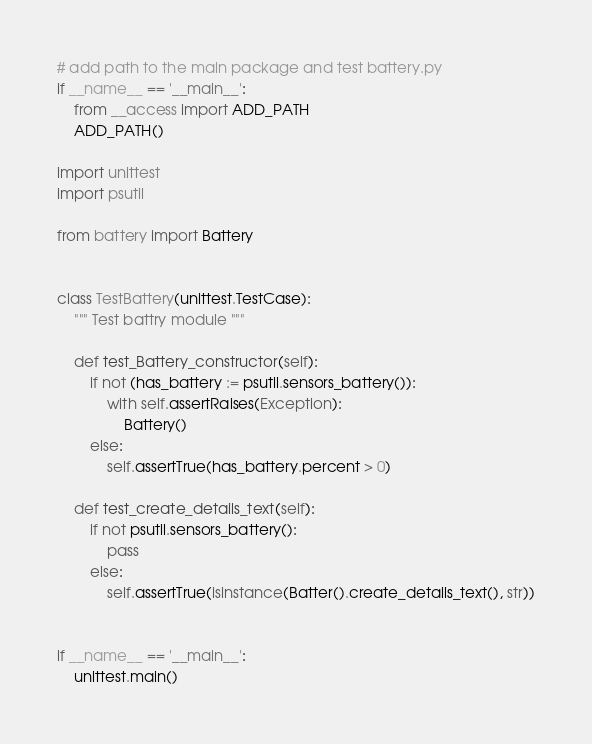<code> <loc_0><loc_0><loc_500><loc_500><_Python_># add path to the main package and test battery.py
if __name__ == '__main__':
    from __access import ADD_PATH
    ADD_PATH()

import unittest
import psutil

from battery import Battery


class TestBattery(unittest.TestCase):
    """ Test battry module """

    def test_Battery_constructor(self):
        if not (has_battery := psutil.sensors_battery()):
            with self.assertRaises(Exception):
                Battery()
        else:
            self.assertTrue(has_battery.percent > 0)

    def test_create_details_text(self):
        if not psutil.sensors_battery():
            pass
        else:
            self.assertTrue(isinstance(Batter().create_details_text(), str))


if __name__ == '__main__':
    unittest.main()</code> 